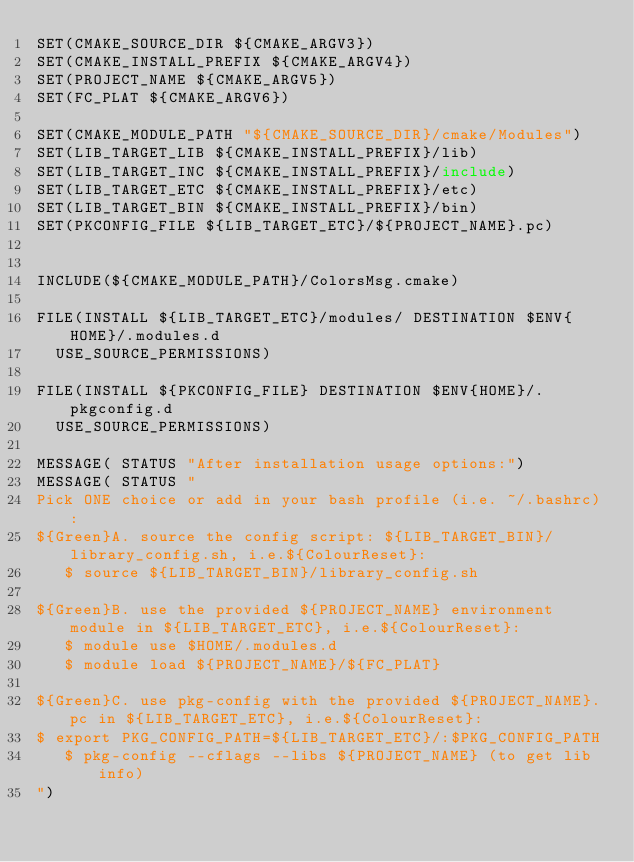<code> <loc_0><loc_0><loc_500><loc_500><_CMake_>SET(CMAKE_SOURCE_DIR ${CMAKE_ARGV3})
SET(CMAKE_INSTALL_PREFIX ${CMAKE_ARGV4})
SET(PROJECT_NAME ${CMAKE_ARGV5})
SET(FC_PLAT ${CMAKE_ARGV6})

SET(CMAKE_MODULE_PATH "${CMAKE_SOURCE_DIR}/cmake/Modules")
SET(LIB_TARGET_LIB ${CMAKE_INSTALL_PREFIX}/lib)
SET(LIB_TARGET_INC ${CMAKE_INSTALL_PREFIX}/include)
SET(LIB_TARGET_ETC ${CMAKE_INSTALL_PREFIX}/etc)
SET(LIB_TARGET_BIN ${CMAKE_INSTALL_PREFIX}/bin)
SET(PKCONFIG_FILE ${LIB_TARGET_ETC}/${PROJECT_NAME}.pc)


INCLUDE(${CMAKE_MODULE_PATH}/ColorsMsg.cmake)

FILE(INSTALL ${LIB_TARGET_ETC}/modules/ DESTINATION $ENV{HOME}/.modules.d
  USE_SOURCE_PERMISSIONS)

FILE(INSTALL ${PKCONFIG_FILE} DESTINATION $ENV{HOME}/.pkgconfig.d
  USE_SOURCE_PERMISSIONS)

MESSAGE( STATUS "After installation usage options:")
MESSAGE( STATUS "
Pick ONE choice or add in your bash profile (i.e. ~/.bashrc):
${Green}A. source the config script: ${LIB_TARGET_BIN}/library_config.sh, i.e.${ColourReset}:
   $ source ${LIB_TARGET_BIN}/library_config.sh

${Green}B. use the provided ${PROJECT_NAME} environment module in ${LIB_TARGET_ETC}, i.e.${ColourReset}:
   $ module use $HOME/.modules.d
   $ module load ${PROJECT_NAME}/${FC_PLAT}

${Green}C. use pkg-config with the provided ${PROJECT_NAME}.pc in ${LIB_TARGET_ETC}, i.e.${ColourReset}:
$ export PKG_CONFIG_PATH=${LIB_TARGET_ETC}/:$PKG_CONFIG_PATH
   $ pkg-config --cflags --libs ${PROJECT_NAME} (to get lib info)
")
</code> 